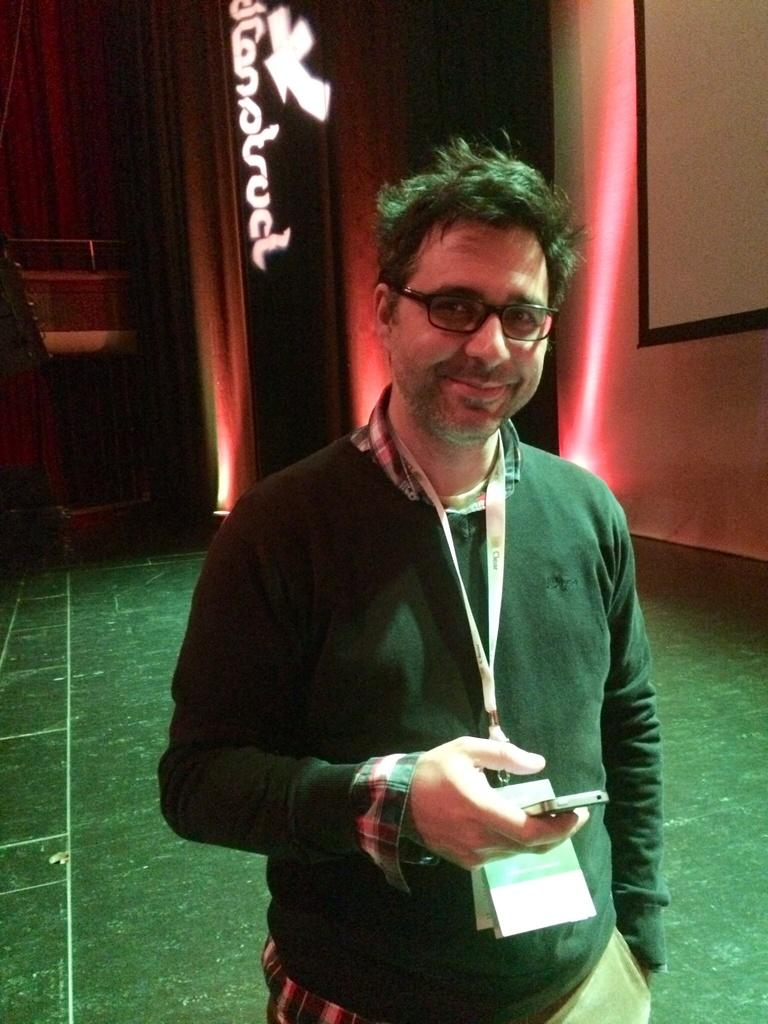What is the man in the image wearing? The man is wearing an ID card and spectacles. What is the man holding in the image? The man is holding a mobile with his hand. What is the man's facial expression in the image? The man is smiling in the image. What can be seen in the background of the image? There is a floor, a wall, and objects visible in the background of the image. What type of stew is being prepared in the image? There is no stew present in the image; it features a man wearing an ID card, spectacles, and holding a mobile. What is the purpose of the alarm in the image? There is no alarm present in the image. 